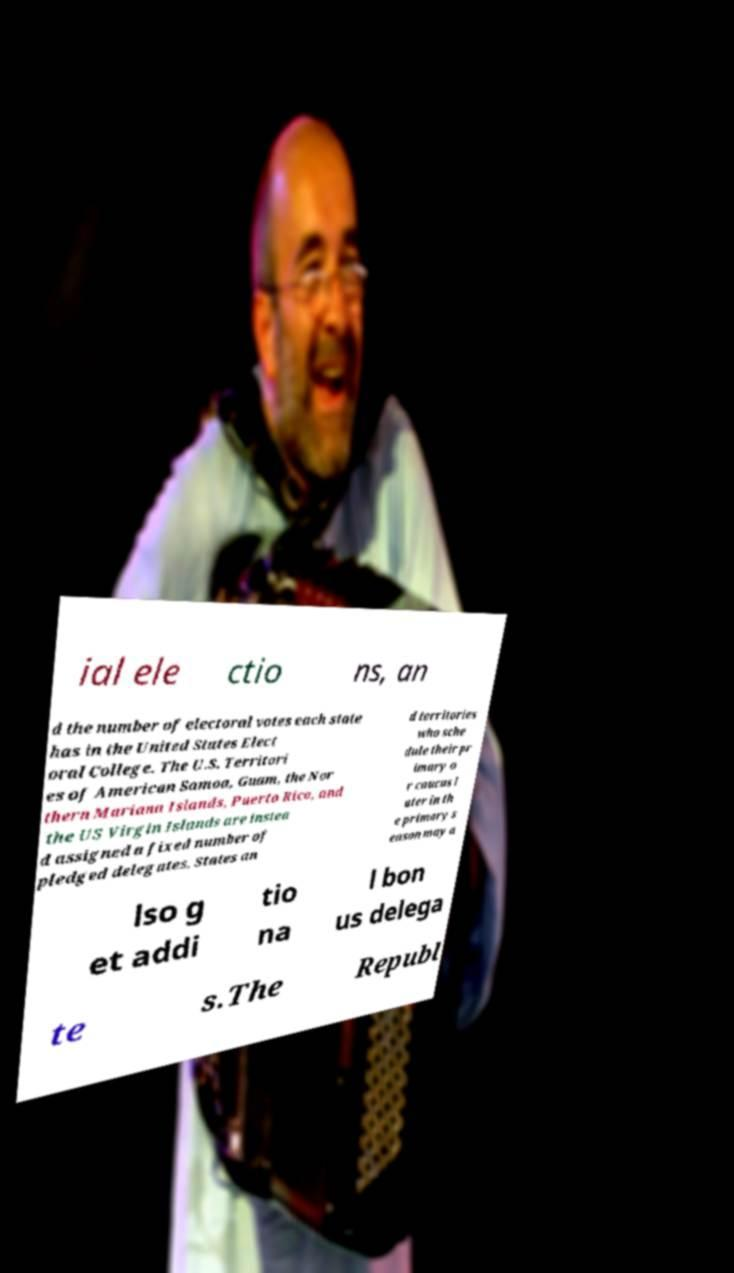Please read and relay the text visible in this image. What does it say? ial ele ctio ns, an d the number of electoral votes each state has in the United States Elect oral College. The U.S. Territori es of American Samoa, Guam, the Nor thern Mariana Islands, Puerto Rico, and the US Virgin Islands are instea d assigned a fixed number of pledged delegates. States an d territories who sche dule their pr imary o r caucus l ater in th e primary s eason may a lso g et addi tio na l bon us delega te s.The Republ 